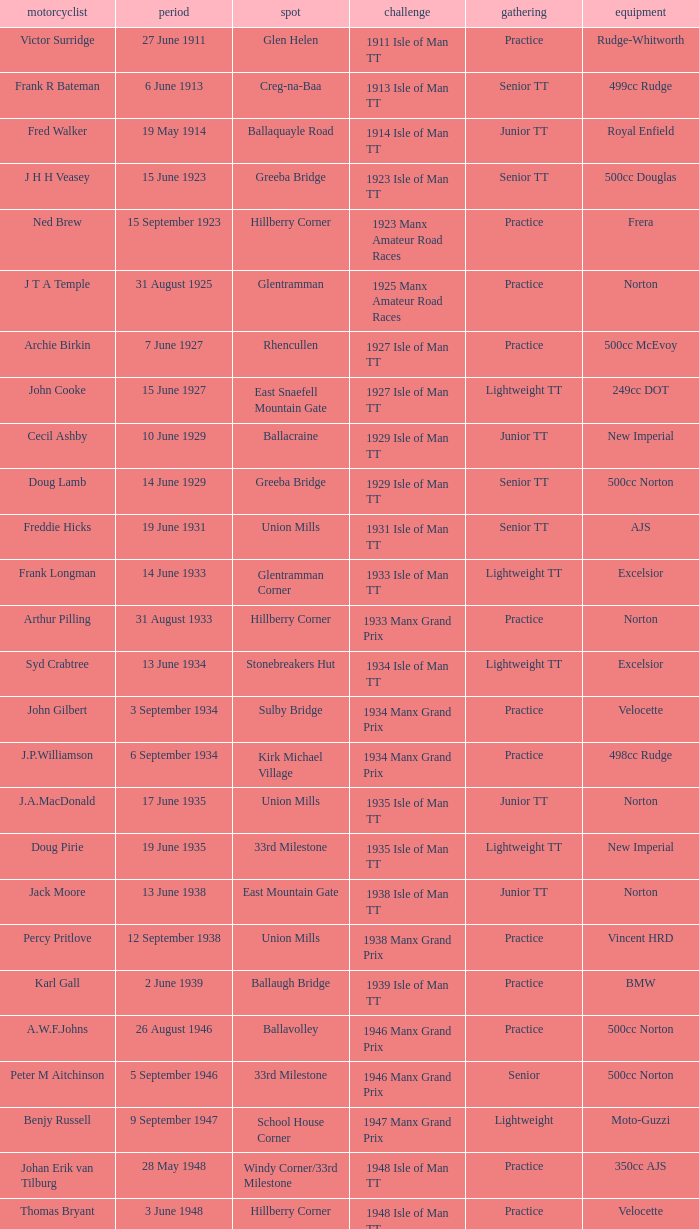What machine did Keith T. Gawler ride? 499cc Norton. 